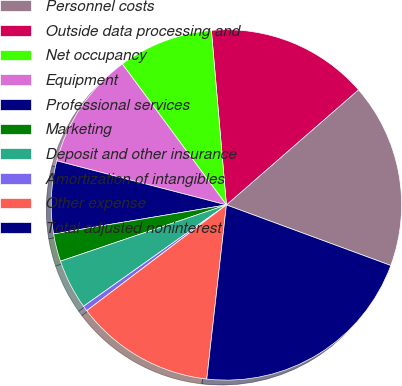Convert chart. <chart><loc_0><loc_0><loc_500><loc_500><pie_chart><fcel>Personnel costs<fcel>Outside data processing and<fcel>Net occupancy<fcel>Equipment<fcel>Professional services<fcel>Marketing<fcel>Deposit and other insurance<fcel>Amortization of intangibles<fcel>Other expense<fcel>Total adjusted noninterest<nl><fcel>17.03%<fcel>14.96%<fcel>8.76%<fcel>10.83%<fcel>6.69%<fcel>2.56%<fcel>4.62%<fcel>0.49%<fcel>12.9%<fcel>21.17%<nl></chart> 